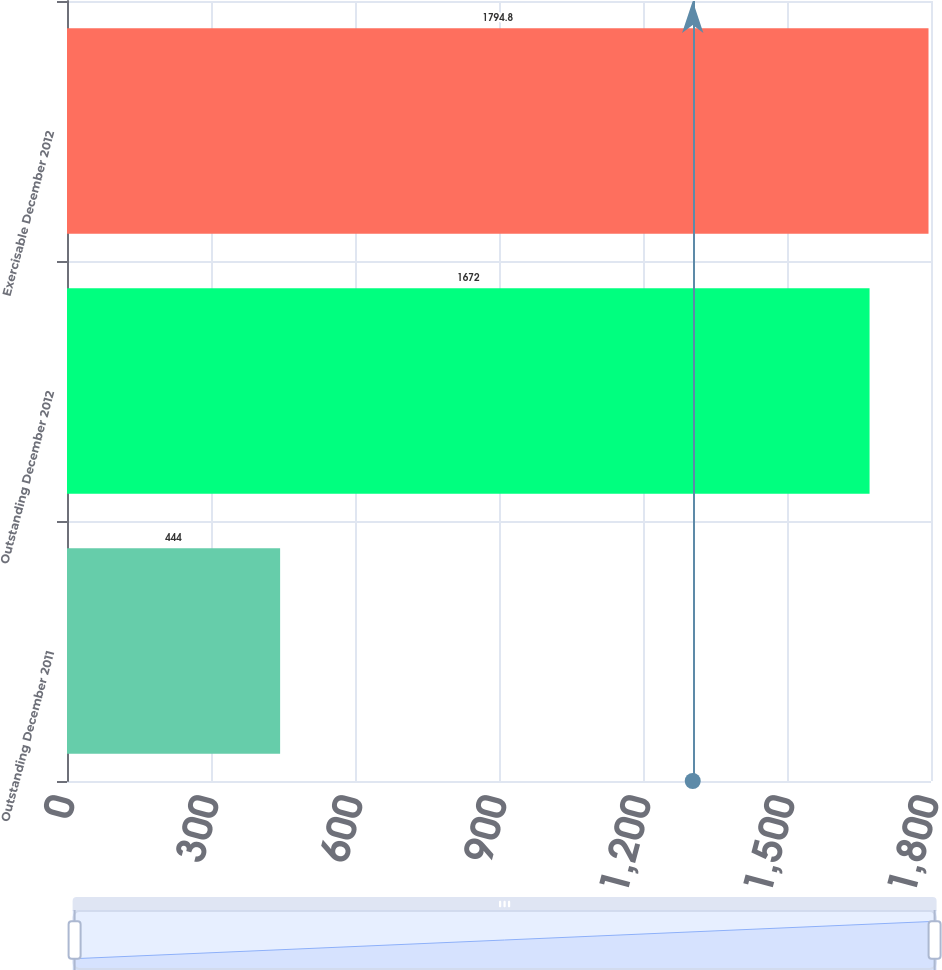<chart> <loc_0><loc_0><loc_500><loc_500><bar_chart><fcel>Outstanding December 2011<fcel>Outstanding December 2012<fcel>Exercisable December 2012<nl><fcel>444<fcel>1672<fcel>1794.8<nl></chart> 